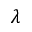<formula> <loc_0><loc_0><loc_500><loc_500>\lambda</formula> 